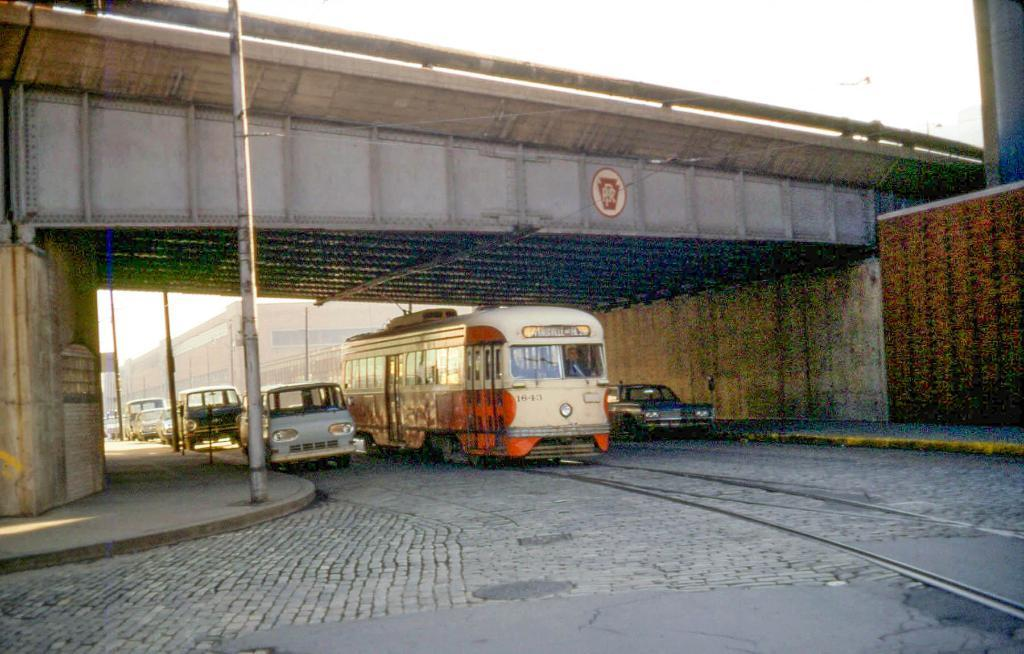What types of transportation can be seen on the road in the image? There are vehicles on the road in the image. What mode of transportation is on the railway track in the image? There is a train on the railway track in the image. What structure is present in the image that allows vehicles to pass over an obstacle? There is a bridge in the image. What type of structure can be seen in the image that is typically used for housing or commercial purposes? There is a building in the image. What can be seen in the background of the image that covers the majority of the sky? The sky is visible in the background of the image. How many pens are visible on the bridge in the image? There are no pens present in the image, and the bridge is not a location where pens would typically be found. 